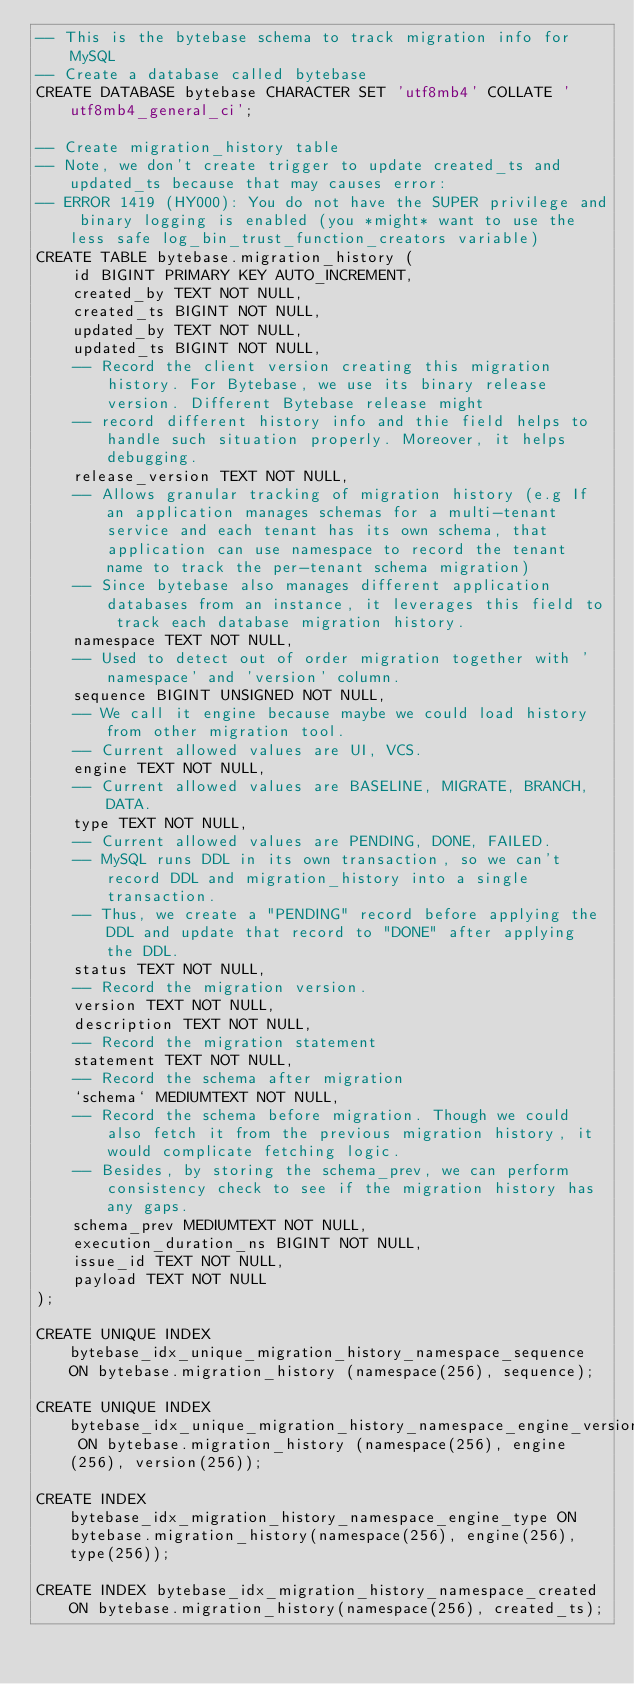Convert code to text. <code><loc_0><loc_0><loc_500><loc_500><_SQL_>-- This is the bytebase schema to track migration info for MySQL
-- Create a database called bytebase
CREATE DATABASE bytebase CHARACTER SET 'utf8mb4' COLLATE 'utf8mb4_general_ci';

-- Create migration_history table
-- Note, we don't create trigger to update created_ts and updated_ts because that may causes error:
-- ERROR 1419 (HY000): You do not have the SUPER privilege and binary logging is enabled (you *might* want to use the less safe log_bin_trust_function_creators variable)
CREATE TABLE bytebase.migration_history (
    id BIGINT PRIMARY KEY AUTO_INCREMENT,
    created_by TEXT NOT NULL,
    created_ts BIGINT NOT NULL,
    updated_by TEXT NOT NULL,
    updated_ts BIGINT NOT NULL,
    -- Record the client version creating this migration history. For Bytebase, we use its binary release version. Different Bytebase release might
    -- record different history info and thie field helps to handle such situation properly. Moreover, it helps debugging.
    release_version TEXT NOT NULL,
    -- Allows granular tracking of migration history (e.g If an application manages schemas for a multi-tenant service and each tenant has its own schema, that application can use namespace to record the tenant name to track the per-tenant schema migration)
    -- Since bytebase also manages different application databases from an instance, it leverages this field to track each database migration history.
    namespace TEXT NOT NULL,
    -- Used to detect out of order migration together with 'namespace' and 'version' column.
    sequence BIGINT UNSIGNED NOT NULL,
    -- We call it engine because maybe we could load history from other migration tool.
    -- Current allowed values are UI, VCS.
    engine TEXT NOT NULL,
    -- Current allowed values are BASELINE, MIGRATE, BRANCH, DATA.
    type TEXT NOT NULL,
    -- Current allowed values are PENDING, DONE, FAILED.
    -- MySQL runs DDL in its own transaction, so we can't record DDL and migration_history into a single transaction.
    -- Thus, we create a "PENDING" record before applying the DDL and update that record to "DONE" after applying the DDL.
    status TEXT NOT NULL,
    -- Record the migration version.
    version TEXT NOT NULL,
    description TEXT NOT NULL,
    -- Record the migration statement
    statement TEXT NOT NULL,
    -- Record the schema after migration
    `schema` MEDIUMTEXT NOT NULL,
    -- Record the schema before migration. Though we could also fetch it from the previous migration history, it would complicate fetching logic.
    -- Besides, by storing the schema_prev, we can perform consistency check to see if the migration history has any gaps.
    schema_prev MEDIUMTEXT NOT NULL,
    execution_duration_ns BIGINT NOT NULL,
    issue_id TEXT NOT NULL,
    payload TEXT NOT NULL
);

CREATE UNIQUE INDEX bytebase_idx_unique_migration_history_namespace_sequence ON bytebase.migration_history (namespace(256), sequence);

CREATE UNIQUE INDEX bytebase_idx_unique_migration_history_namespace_engine_version ON bytebase.migration_history (namespace(256), engine(256), version(256));

CREATE INDEX bytebase_idx_migration_history_namespace_engine_type ON bytebase.migration_history(namespace(256), engine(256), type(256));

CREATE INDEX bytebase_idx_migration_history_namespace_created ON bytebase.migration_history(namespace(256), created_ts);
</code> 